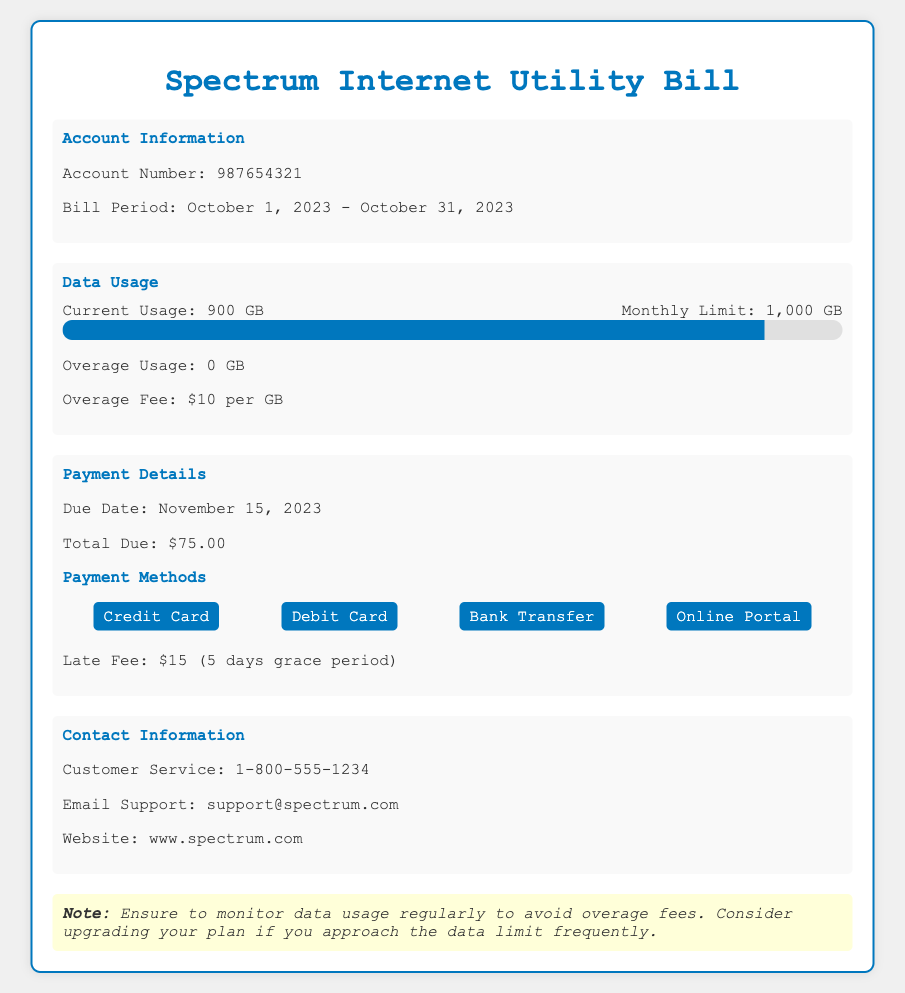what is the account number? The account number is specified in the document as a unique identifier for the account, which is 987654321.
Answer: 987654321 what is the monthly data limit? The document explicitly states the maximum data usage allowed per month, which is 1,000 GB.
Answer: 1,000 GB what is the current data usage? The current usage of data for this billing period is indicated in the document as 900 GB.
Answer: 900 GB what is the total amount due? The total payment required for this bill is provided in the document, which is $75.00.
Answer: $75.00 what is the overage fee? The document specifies the cost incurred for exceeding the data limit as $10 per GB.
Answer: $10 per GB when is the payment due date? The document mentions a specific date by which the payment must be made, which is November 15, 2023.
Answer: November 15, 2023 how many days is the grace period for late fee? The document indicates a grace period for late payments before a fee incurs, which is 5 days.
Answer: 5 days what should you monitor to avoid overage fees? The document advises that you should keep track of your data usage to prevent additional charges.
Answer: data usage what payment methods are available? The document lists the options for paying the bill, including different methods such as Credit Card, Debit Card, Bank Transfer, and Online Portal.
Answer: Credit Card, Debit Card, Bank Transfer, Online Portal 